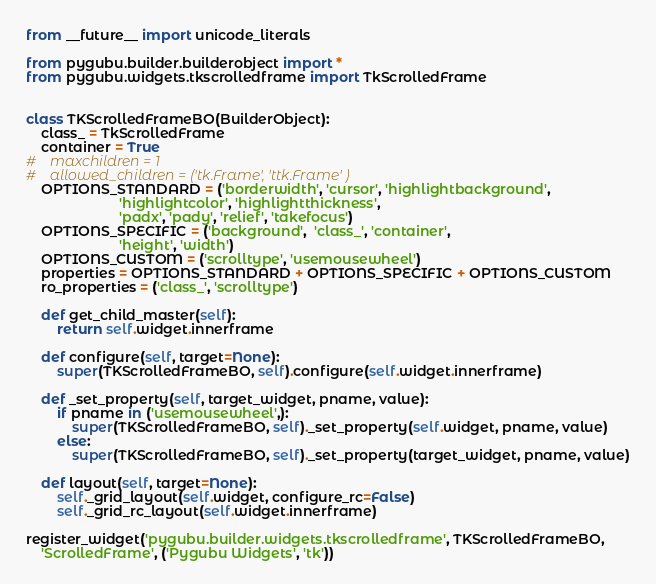Convert code to text. <code><loc_0><loc_0><loc_500><loc_500><_Python_>from __future__ import unicode_literals

from pygubu.builder.builderobject import *
from pygubu.widgets.tkscrolledframe import TkScrolledFrame


class TKScrolledFrameBO(BuilderObject):
    class_ = TkScrolledFrame
    container = True
#    maxchildren = 1
#    allowed_children = ('tk.Frame', 'ttk.Frame' )
    OPTIONS_STANDARD = ('borderwidth', 'cursor', 'highlightbackground',
                        'highlightcolor', 'highlightthickness',
                        'padx', 'pady', 'relief', 'takefocus')
    OPTIONS_SPECIFIC = ('background',  'class_', 'container',
                        'height', 'width')
    OPTIONS_CUSTOM = ('scrolltype', 'usemousewheel')
    properties = OPTIONS_STANDARD + OPTIONS_SPECIFIC + OPTIONS_CUSTOM
    ro_properties = ('class_', 'scrolltype')

    def get_child_master(self):
        return self.widget.innerframe

    def configure(self, target=None):
        super(TKScrolledFrameBO, self).configure(self.widget.innerframe)
        
    def _set_property(self, target_widget, pname, value):
        if pname in ('usemousewheel',):
            super(TKScrolledFrameBO, self)._set_property(self.widget, pname, value)
        else:
            super(TKScrolledFrameBO, self)._set_property(target_widget, pname, value)

    def layout(self, target=None):
        self._grid_layout(self.widget, configure_rc=False)
        self._grid_rc_layout(self.widget.innerframe)

register_widget('pygubu.builder.widgets.tkscrolledframe', TKScrolledFrameBO,
    'ScrolledFrame', ('Pygubu Widgets', 'tk'))
</code> 